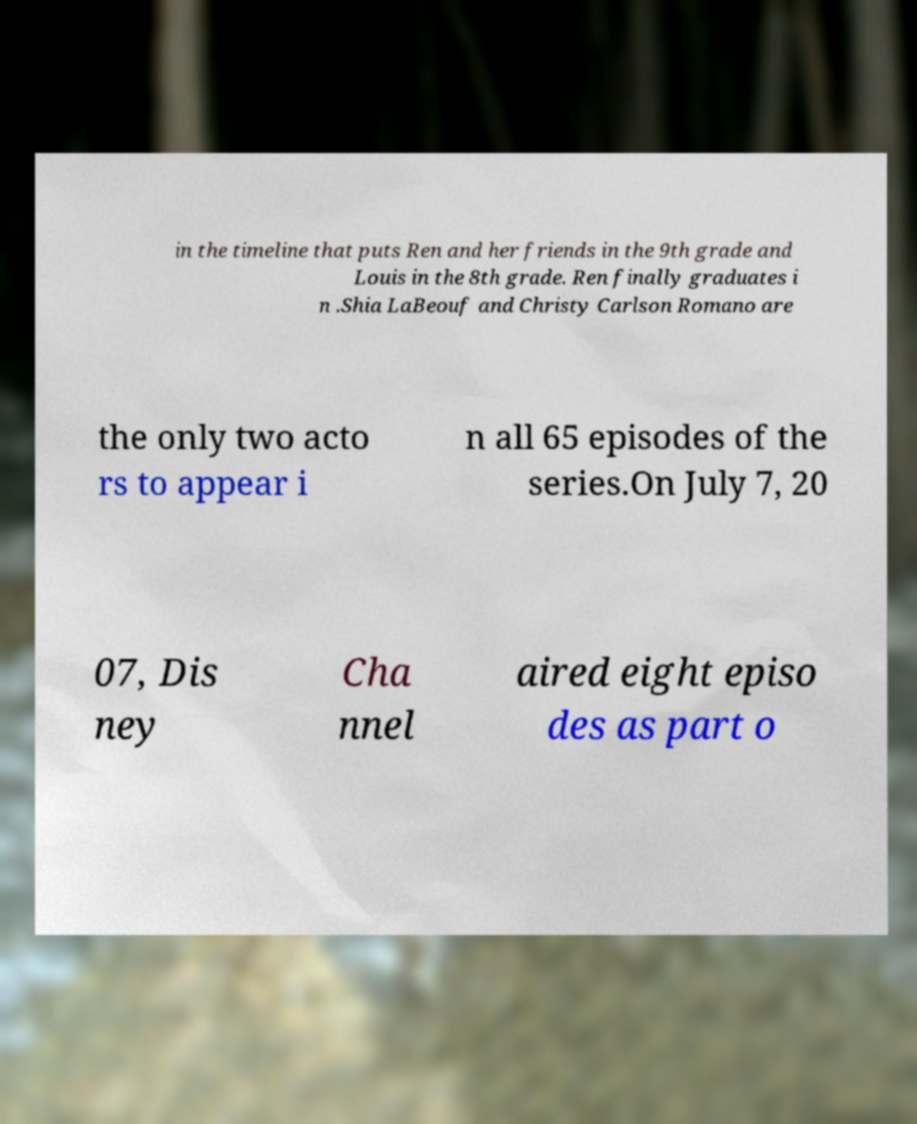I need the written content from this picture converted into text. Can you do that? in the timeline that puts Ren and her friends in the 9th grade and Louis in the 8th grade. Ren finally graduates i n .Shia LaBeouf and Christy Carlson Romano are the only two acto rs to appear i n all 65 episodes of the series.On July 7, 20 07, Dis ney Cha nnel aired eight episo des as part o 